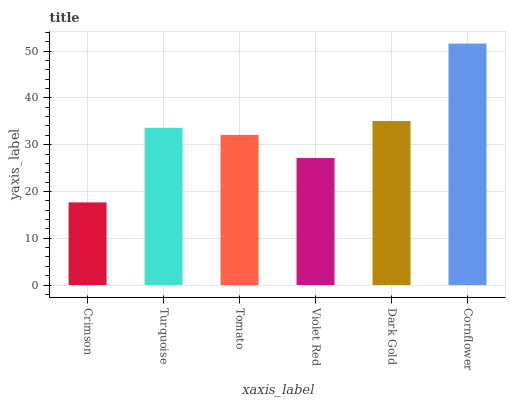Is Crimson the minimum?
Answer yes or no. Yes. Is Cornflower the maximum?
Answer yes or no. Yes. Is Turquoise the minimum?
Answer yes or no. No. Is Turquoise the maximum?
Answer yes or no. No. Is Turquoise greater than Crimson?
Answer yes or no. Yes. Is Crimson less than Turquoise?
Answer yes or no. Yes. Is Crimson greater than Turquoise?
Answer yes or no. No. Is Turquoise less than Crimson?
Answer yes or no. No. Is Turquoise the high median?
Answer yes or no. Yes. Is Tomato the low median?
Answer yes or no. Yes. Is Dark Gold the high median?
Answer yes or no. No. Is Crimson the low median?
Answer yes or no. No. 